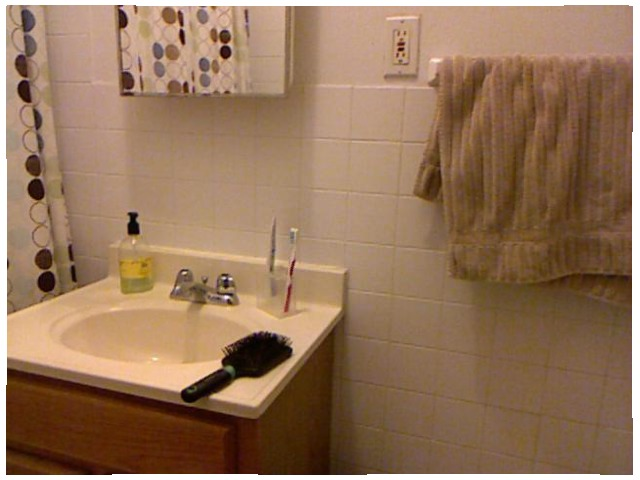<image>
Is there a hair brush under the outlet? Yes. The hair brush is positioned underneath the outlet, with the outlet above it in the vertical space. Where is the toothbrush in relation to the box? Is it in the box? Yes. The toothbrush is contained within or inside the box, showing a containment relationship. Is there a brush in the glass? Yes. The brush is contained within or inside the glass, showing a containment relationship. Is the socket behind the towel? No. The socket is not behind the towel. From this viewpoint, the socket appears to be positioned elsewhere in the scene. 